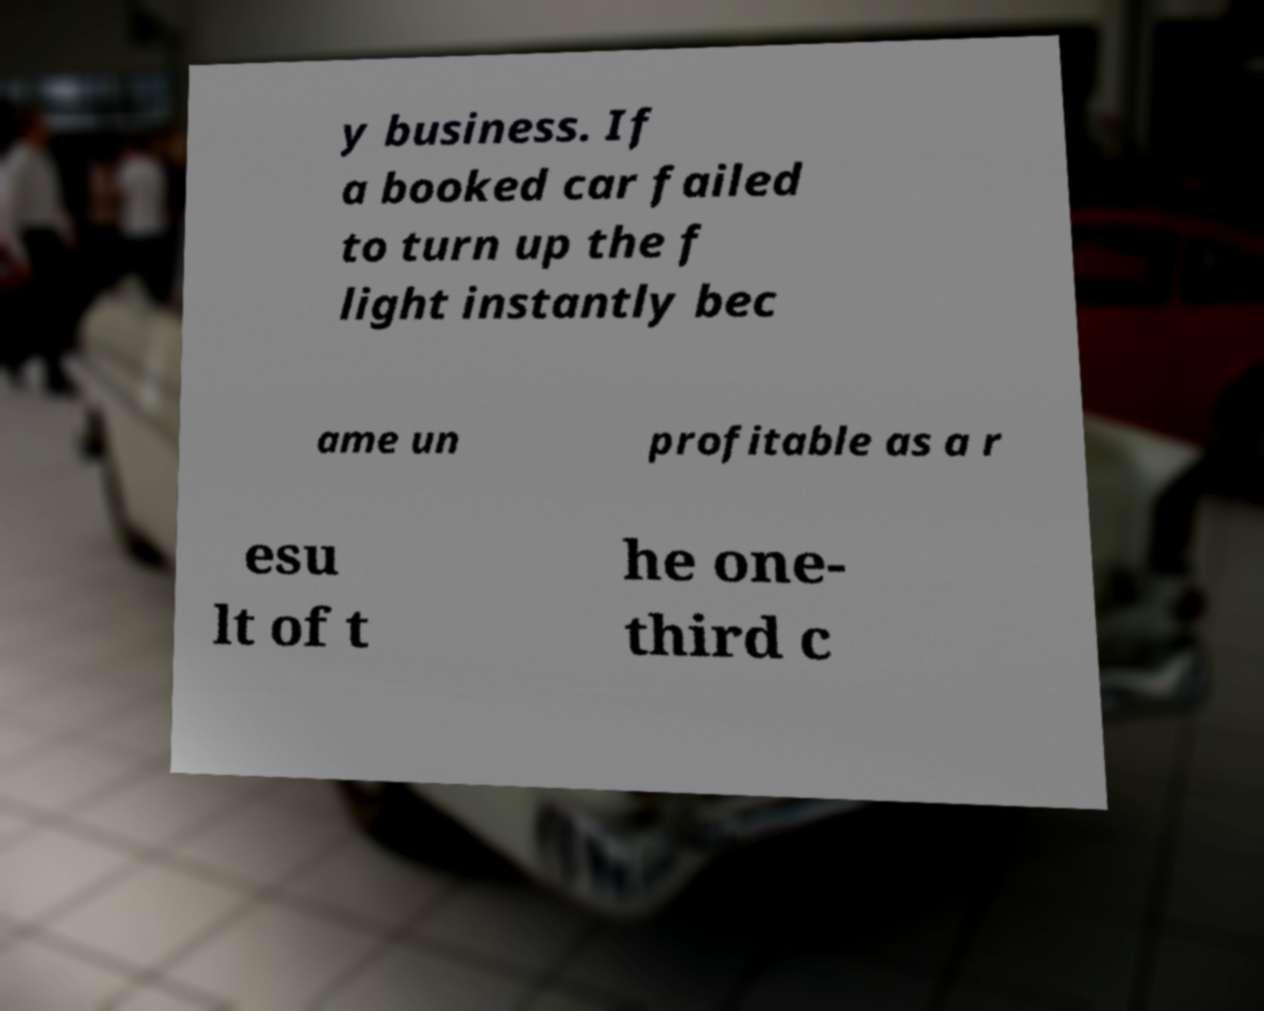Please read and relay the text visible in this image. What does it say? y business. If a booked car failed to turn up the f light instantly bec ame un profitable as a r esu lt of t he one- third c 